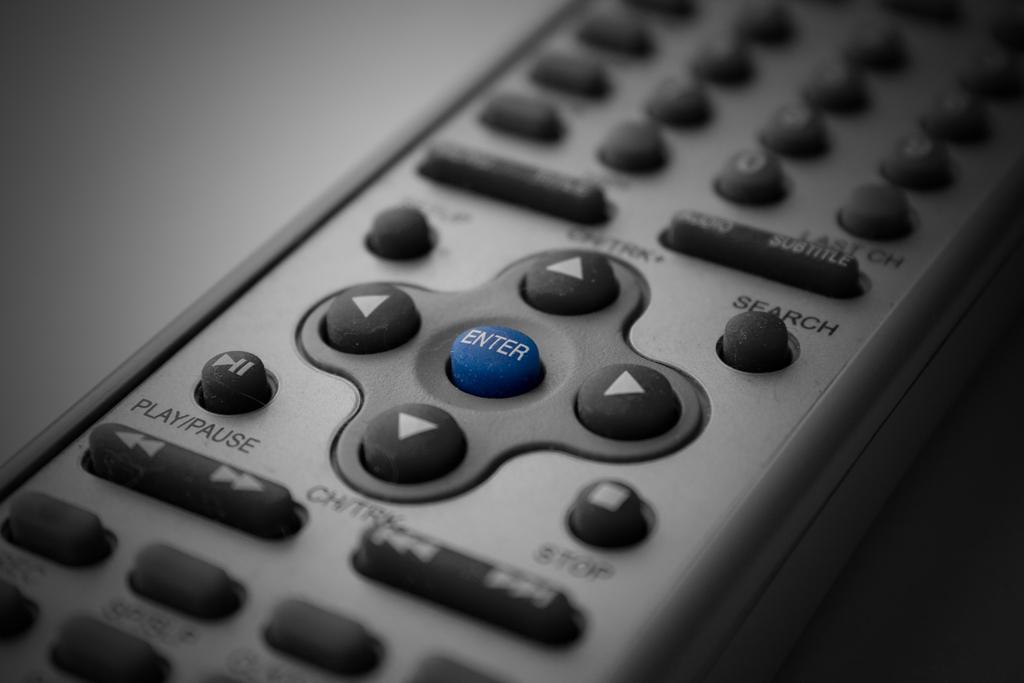What button is blue?
Provide a succinct answer. Enter. 